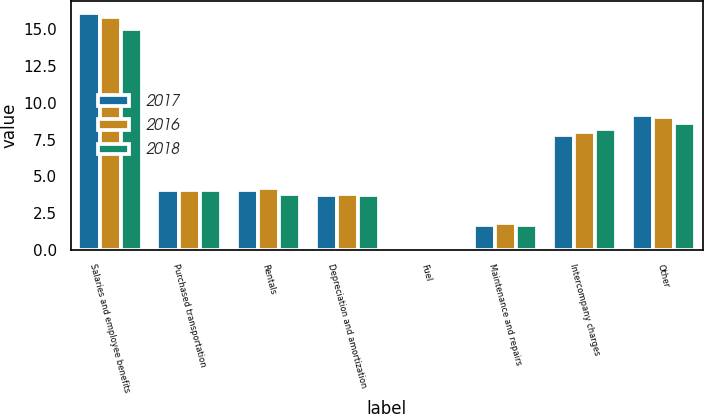Convert chart to OTSL. <chart><loc_0><loc_0><loc_500><loc_500><stacked_bar_chart><ecel><fcel>Salaries and employee benefits<fcel>Purchased transportation<fcel>Rentals<fcel>Depreciation and amortization<fcel>Fuel<fcel>Maintenance and repairs<fcel>Intercompany charges<fcel>Other<nl><fcel>2017<fcel>16.1<fcel>4.1<fcel>4.1<fcel>3.7<fcel>0.1<fcel>1.7<fcel>7.8<fcel>9.2<nl><fcel>2016<fcel>15.8<fcel>4.1<fcel>4.2<fcel>3.8<fcel>0.1<fcel>1.8<fcel>8<fcel>9<nl><fcel>2018<fcel>15<fcel>4.1<fcel>3.8<fcel>3.7<fcel>0.1<fcel>1.7<fcel>8.2<fcel>8.6<nl></chart> 